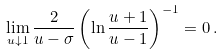<formula> <loc_0><loc_0><loc_500><loc_500>\lim _ { u \downarrow 1 } \frac { 2 } { u - \sigma } \left ( \ln \frac { u + 1 } { u - 1 } \right ) ^ { - 1 } = 0 \, .</formula> 